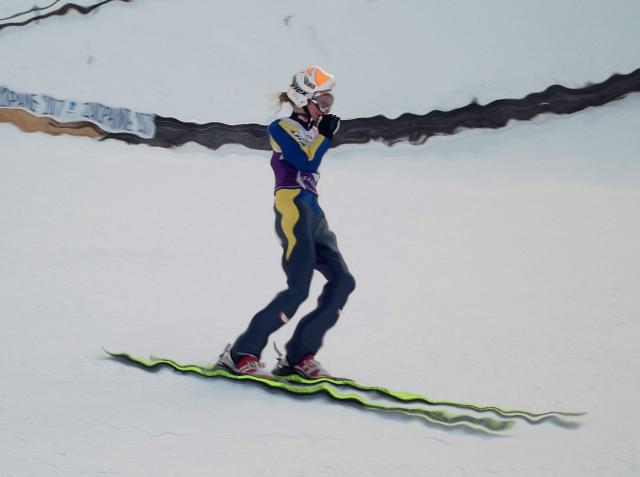Can you describe the environment or setting of the photo? The photo depicts a snowy landscape which is typical for winter sports. The smoothness of the snow implies that this may be a well-maintained area, possibly a ski resort or a snowboard park designed for such activities. 